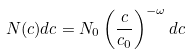<formula> <loc_0><loc_0><loc_500><loc_500>N ( c ) d c = N _ { 0 } \left ( \frac { c } { c _ { 0 } } \right ) ^ { - \omega } d c</formula> 